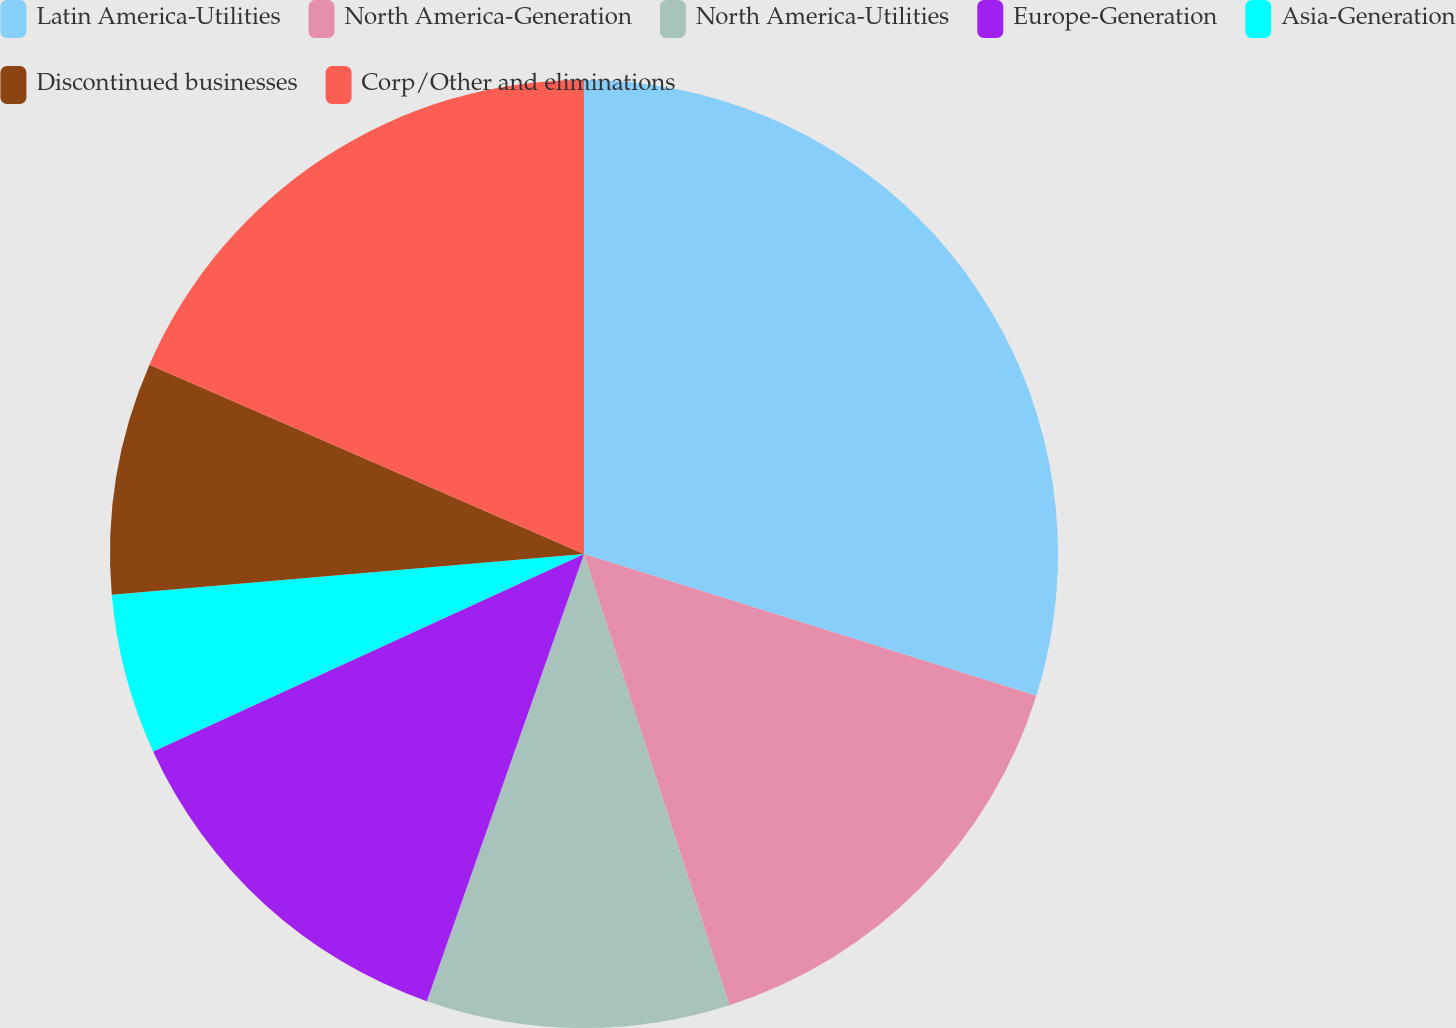Convert chart. <chart><loc_0><loc_0><loc_500><loc_500><pie_chart><fcel>Latin America-Utilities<fcel>North America-Generation<fcel>North America-Utilities<fcel>Europe-Generation<fcel>Asia-Generation<fcel>Discontinued businesses<fcel>Corp/Other and eliminations<nl><fcel>29.83%<fcel>15.21%<fcel>10.34%<fcel>12.78%<fcel>5.47%<fcel>7.91%<fcel>18.46%<nl></chart> 